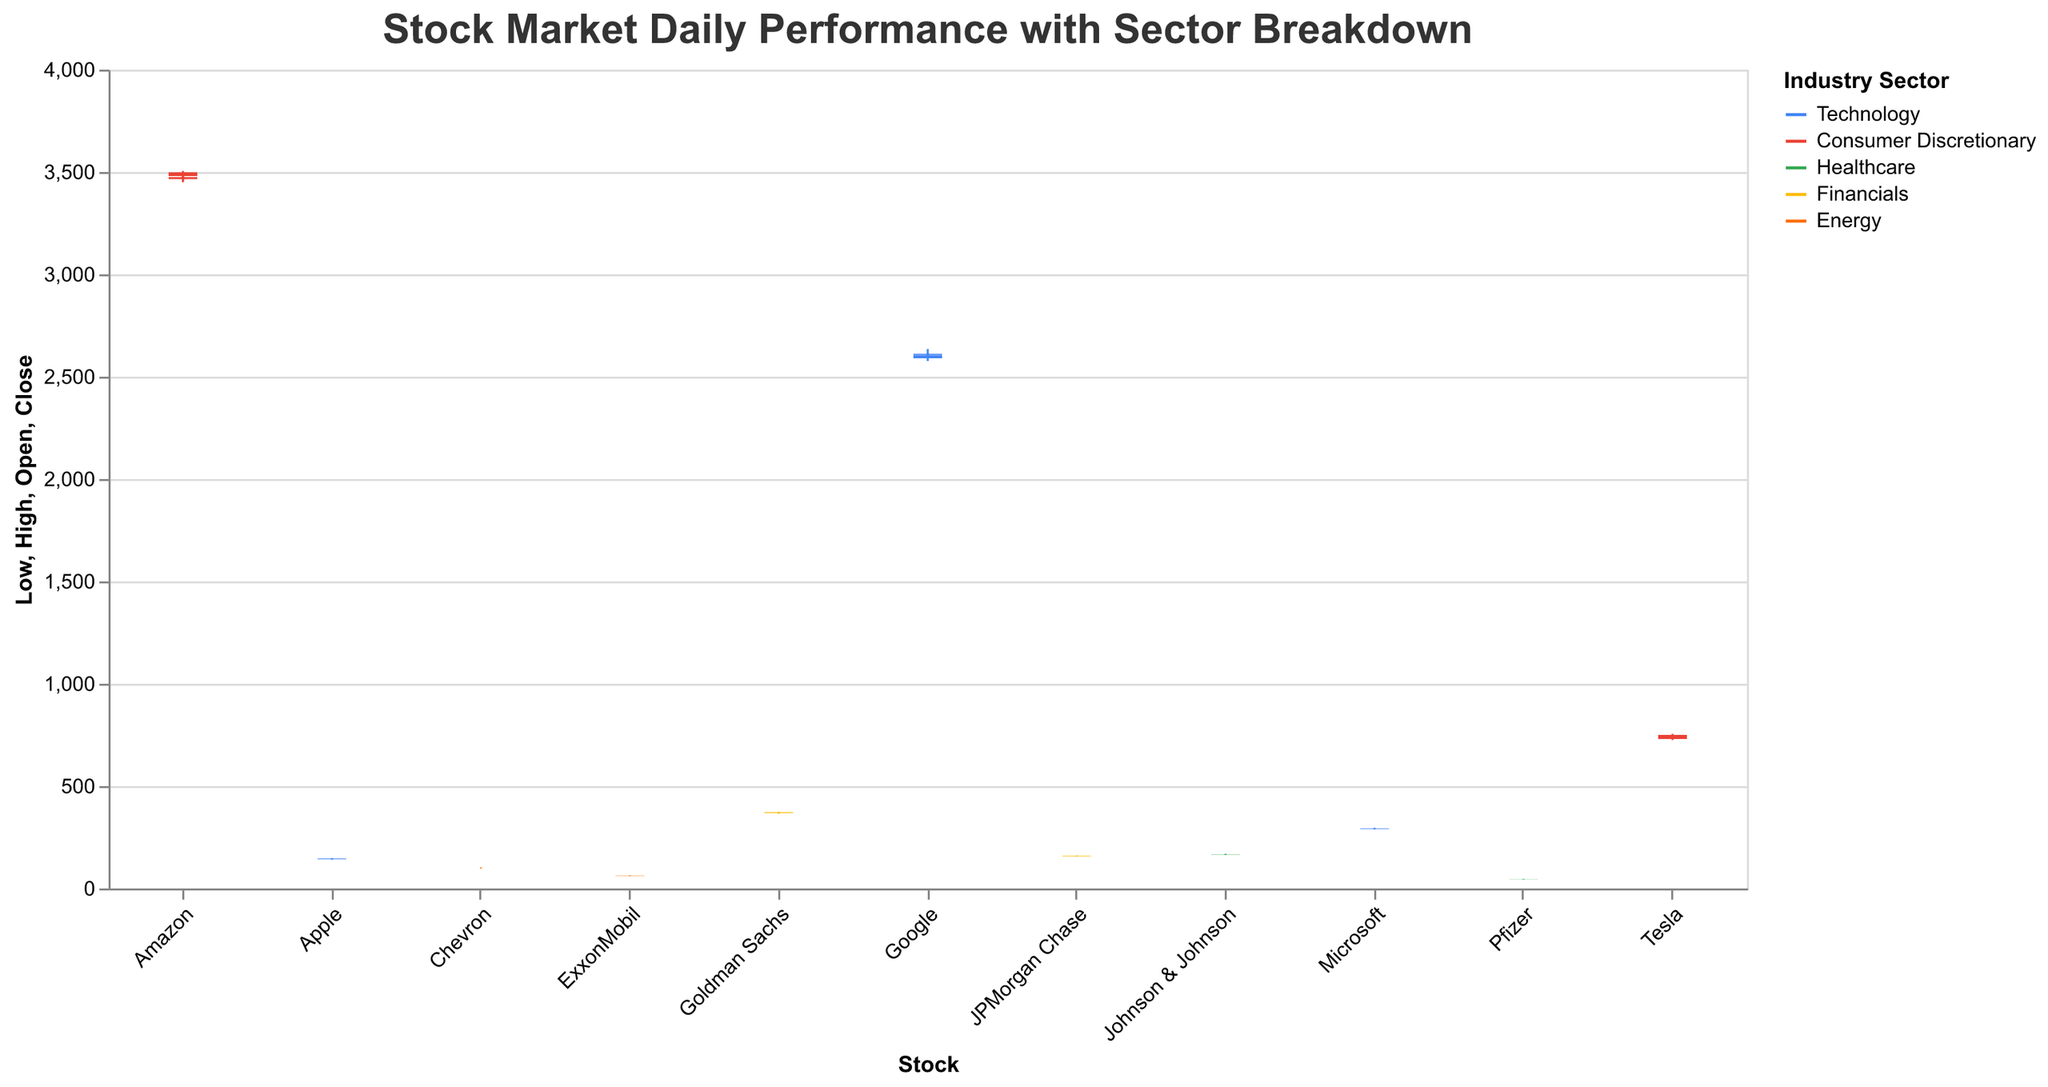What is the title of the figure? The figure's title is displayed prominently at the top of the chart. It reads "Stock Market Daily Performance with Sector Breakdown."
Answer: Stock Market Daily Performance with Sector Breakdown Which industry sector does the color blue represent? Each industry sector is represented by a different color. The color blue represents the Technology sector.
Answer: Technology On October 3rd, which stock had the highest closing price? Looking at the prices on the candlestick plot for October 3rd, the highest closing price was for Amazon, at $3498.0.
Answer: Amazon Which stock showed the most significant increase in closing price from October 2nd to October 3rd? For October 2nd and October 3rd, calculate the difference between the closing prices for each stock. Tesla increased from $740.0 to $750.0, which is the highest increase of $10.0.
Answer: Tesla How many stocks are shown within the Financials sector across both dates? By counting the occurrences of stocks labeled under the Financials sector in the dataset, we find there are two stocks: JPMorgan Chase and Goldman Sachs, appearing on both dates. This gives us a total of 4 data points.
Answer: 4 Which stock had the highest trading volume on October 2nd? Examining the trading volumes for October 2nd, Tesla had the highest volume, which is 24,032,000.
Answer: Tesla Which stock had a higher closing price on October 3rd, Microsoft or Google? By comparing the closing prices on October 3rd for Microsoft ($293.5) and Google ($2612.0), Microsoft had a lower closing price than Google.
Answer: Google What is the average closing price of Technology sector stocks on October 2nd? Adding up the closing prices for Technology sector stocks on October 2nd: Apple ($144.1), Microsoft ($292.4), and Google ($2605.0), the sum is $3041.5. There are three stocks, so the average closing price is $3041.5 / 3 = $1013.83.
Answer: $1013.83 Which sector shows the largest range (difference between high and low prices) for any stock on October 2nd? Calculate the range (high - low) for each stock on October 2nd and compare them. Tesla, in the Consumer Discretionary sector, has the largest range ($745.0 - $725.0 = $20.0).
Answer: Consumer Discretionary Which Energy sector stock had a higher closing price on October 3rd? Comparing the closing prices of ExxonMobil ($63.2) and Chevron ($100.9) on October 3rd, Chevron had the higher closing price.
Answer: Chevron 